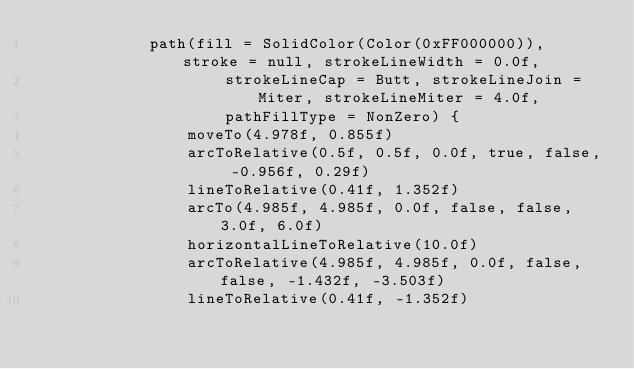Convert code to text. <code><loc_0><loc_0><loc_500><loc_500><_Kotlin_>            path(fill = SolidColor(Color(0xFF000000)), stroke = null, strokeLineWidth = 0.0f,
                    strokeLineCap = Butt, strokeLineJoin = Miter, strokeLineMiter = 4.0f,
                    pathFillType = NonZero) {
                moveTo(4.978f, 0.855f)
                arcToRelative(0.5f, 0.5f, 0.0f, true, false, -0.956f, 0.29f)
                lineToRelative(0.41f, 1.352f)
                arcTo(4.985f, 4.985f, 0.0f, false, false, 3.0f, 6.0f)
                horizontalLineToRelative(10.0f)
                arcToRelative(4.985f, 4.985f, 0.0f, false, false, -1.432f, -3.503f)
                lineToRelative(0.41f, -1.352f)</code> 